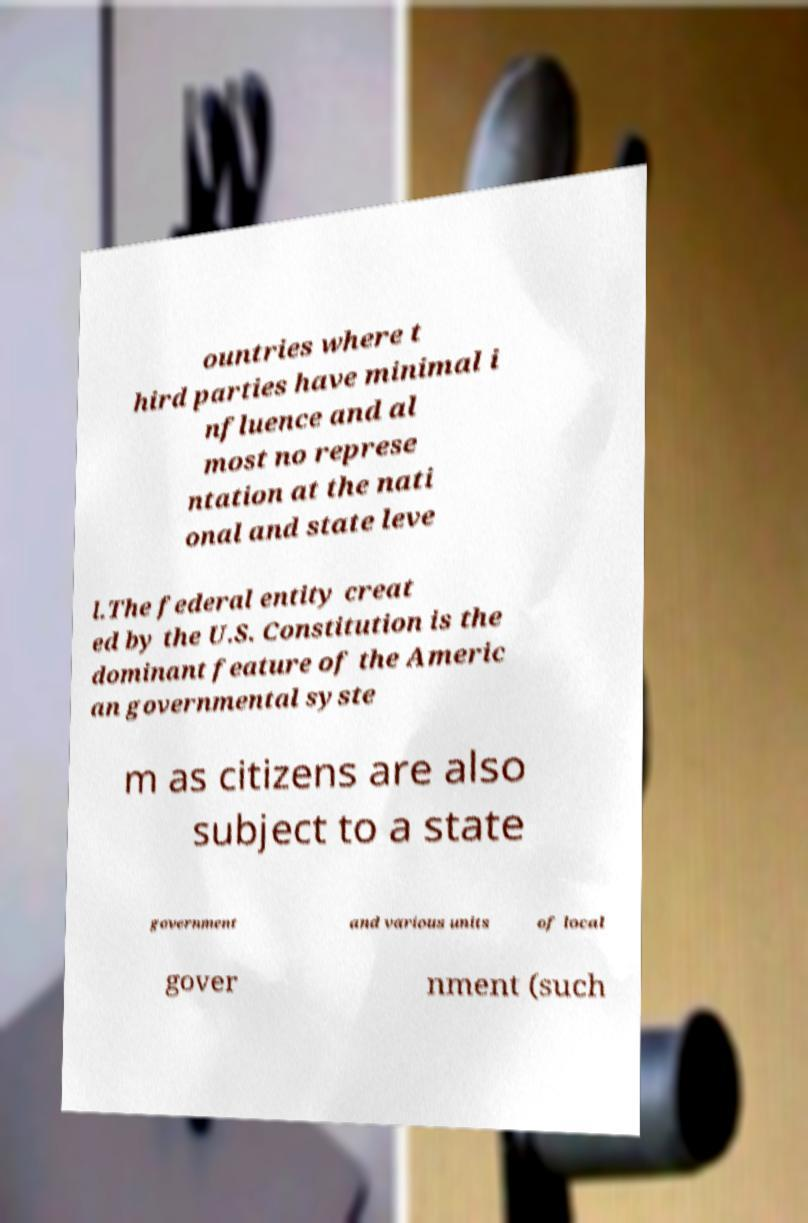Can you accurately transcribe the text from the provided image for me? ountries where t hird parties have minimal i nfluence and al most no represe ntation at the nati onal and state leve l.The federal entity creat ed by the U.S. Constitution is the dominant feature of the Americ an governmental syste m as citizens are also subject to a state government and various units of local gover nment (such 